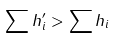<formula> <loc_0><loc_0><loc_500><loc_500>\sum h _ { i } ^ { \prime } > \sum h _ { i }</formula> 